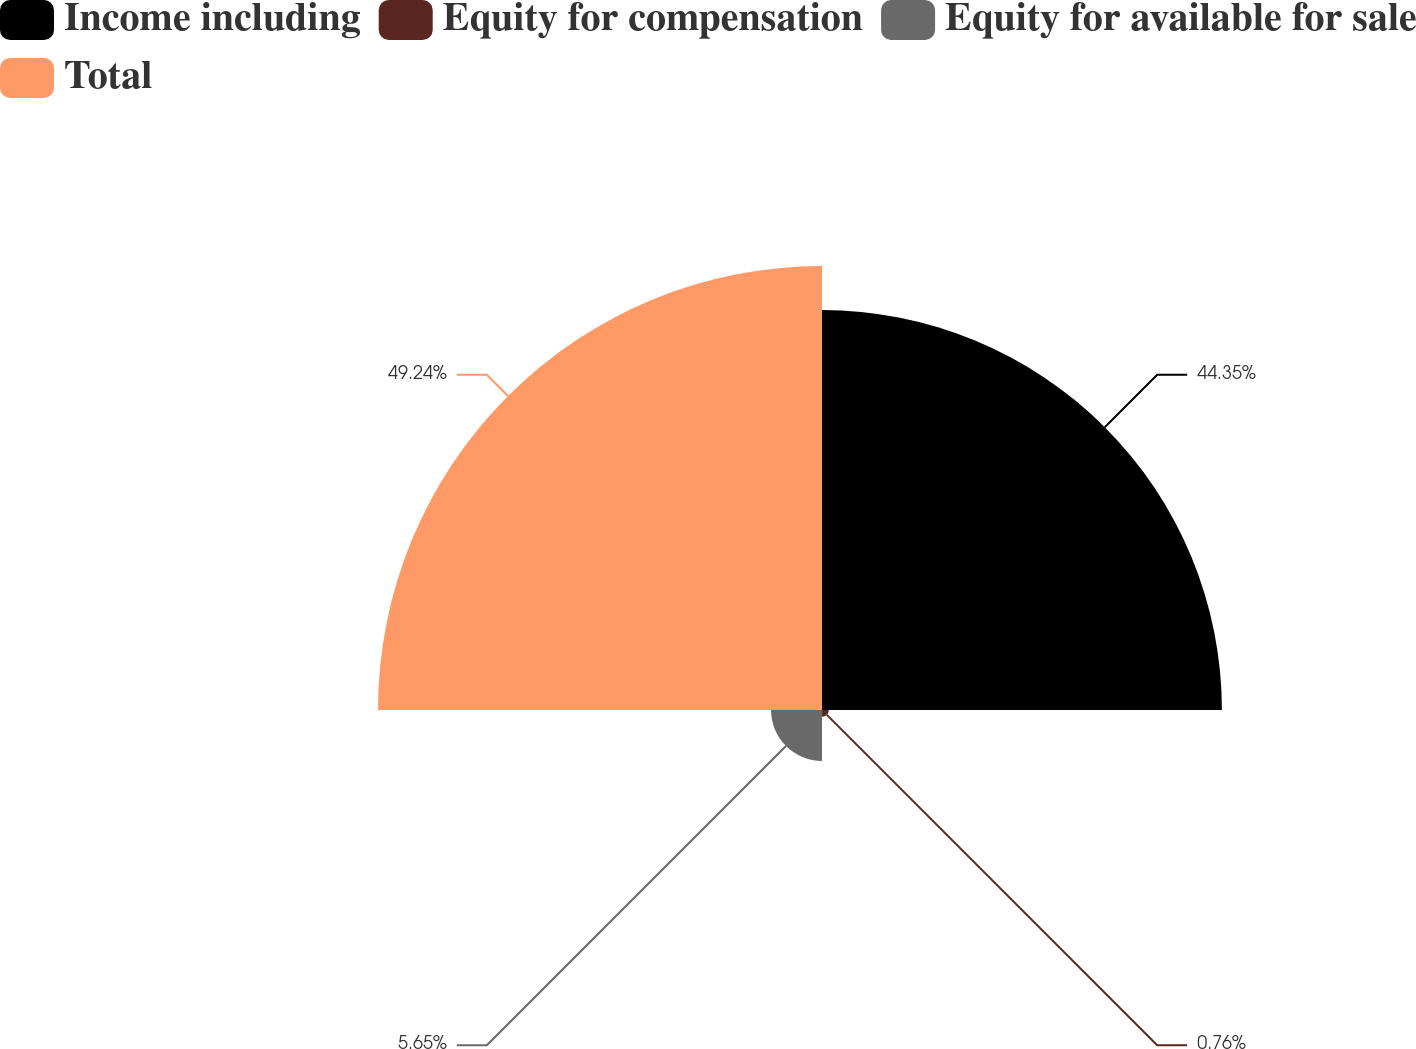<chart> <loc_0><loc_0><loc_500><loc_500><pie_chart><fcel>Income including<fcel>Equity for compensation<fcel>Equity for available for sale<fcel>Total<nl><fcel>44.35%<fcel>0.76%<fcel>5.65%<fcel>49.24%<nl></chart> 